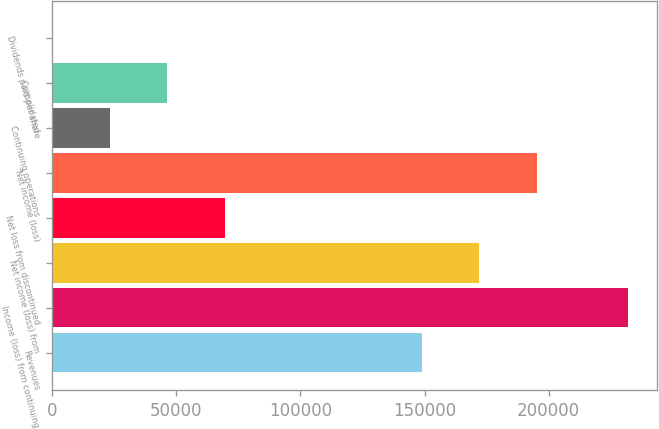<chart> <loc_0><loc_0><loc_500><loc_500><bar_chart><fcel>Revenues<fcel>Income (loss) from continuing<fcel>Net income (loss) from<fcel>Net loss from discontinued<fcel>Net income (loss)<fcel>Continuing operations<fcel>Consolidated<fcel>Dividends paid per share<nl><fcel>148871<fcel>231990<fcel>172070<fcel>69597.2<fcel>195269<fcel>23199.2<fcel>46398.2<fcel>0.25<nl></chart> 